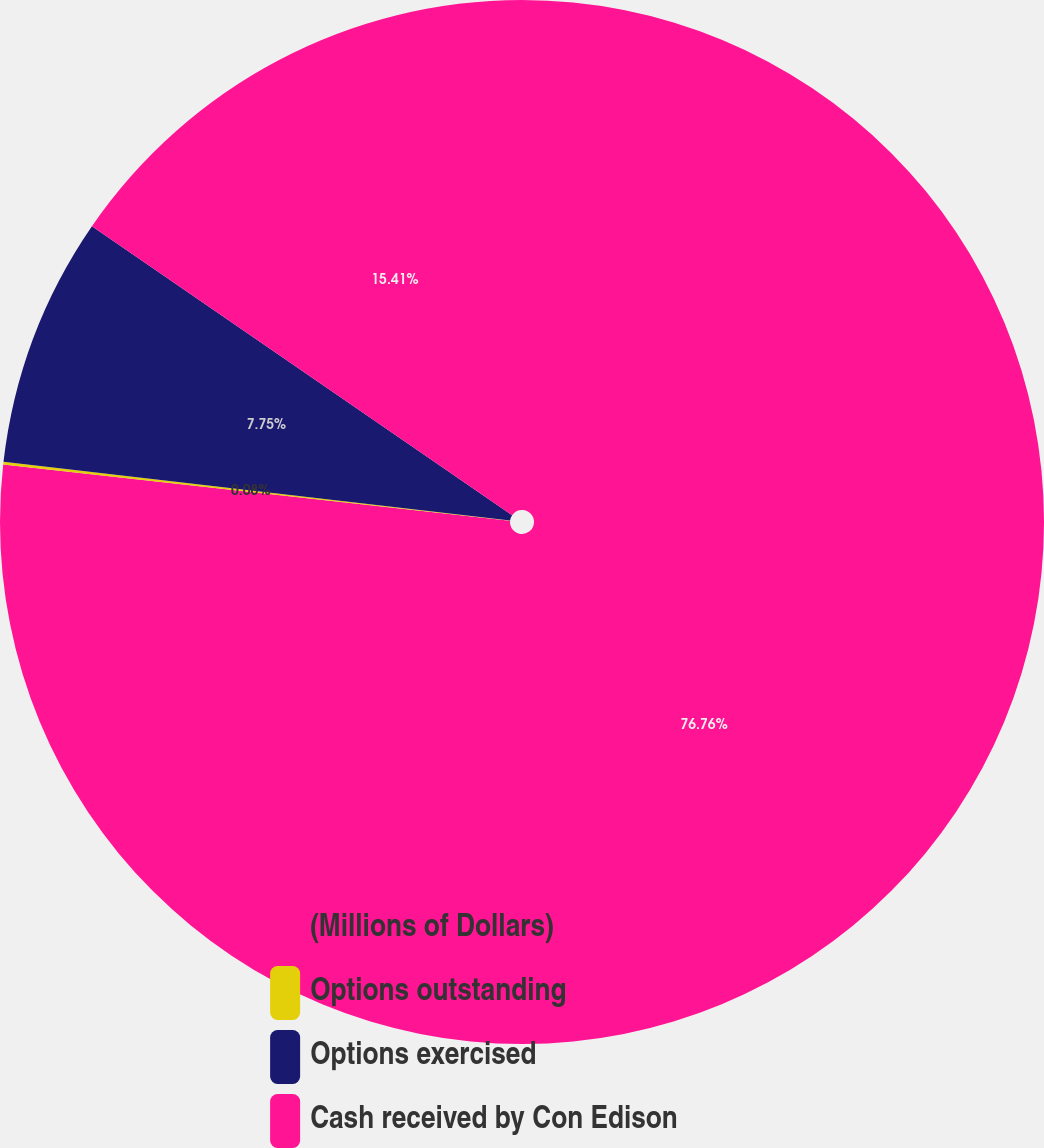Convert chart to OTSL. <chart><loc_0><loc_0><loc_500><loc_500><pie_chart><fcel>(Millions of Dollars)<fcel>Options outstanding<fcel>Options exercised<fcel>Cash received by Con Edison<nl><fcel>76.76%<fcel>0.08%<fcel>7.75%<fcel>15.41%<nl></chart> 